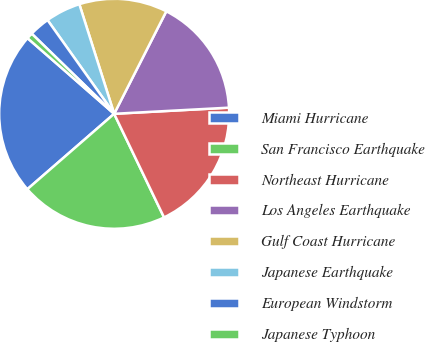<chart> <loc_0><loc_0><loc_500><loc_500><pie_chart><fcel>Miami Hurricane<fcel>San Francisco Earthquake<fcel>Northeast Hurricane<fcel>Los Angeles Earthquake<fcel>Gulf Coast Hurricane<fcel>Japanese Earthquake<fcel>European Windstorm<fcel>Japanese Typhoon<nl><fcel>22.81%<fcel>20.76%<fcel>18.71%<fcel>16.66%<fcel>12.39%<fcel>4.94%<fcel>2.89%<fcel>0.85%<nl></chart> 